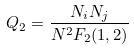Convert formula to latex. <formula><loc_0><loc_0><loc_500><loc_500>Q _ { 2 } = \frac { N _ { i } N _ { j } } { N ^ { 2 } F _ { 2 } ( 1 , 2 ) }</formula> 